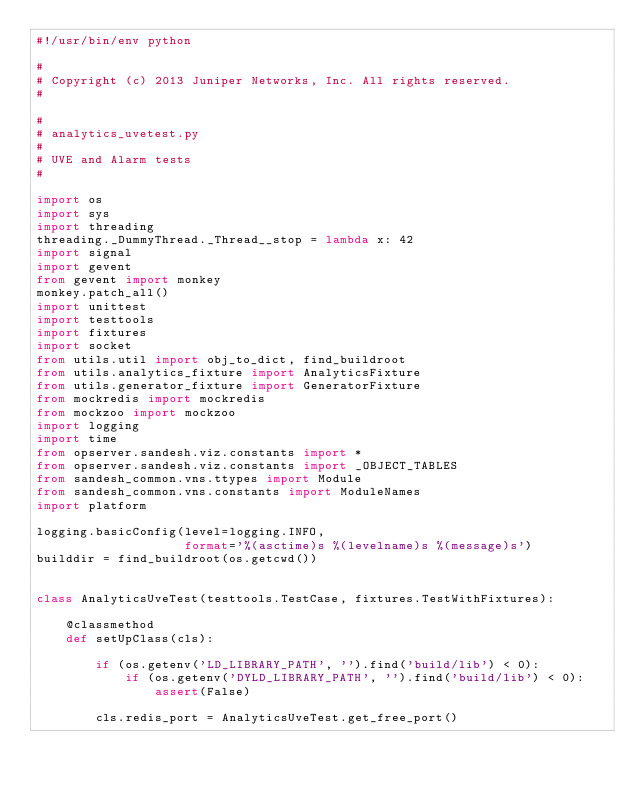Convert code to text. <code><loc_0><loc_0><loc_500><loc_500><_Python_>#!/usr/bin/env python

#
# Copyright (c) 2013 Juniper Networks, Inc. All rights reserved.
#

#
# analytics_uvetest.py
#
# UVE and Alarm tests
#

import os
import sys
import threading
threading._DummyThread._Thread__stop = lambda x: 42
import signal
import gevent
from gevent import monkey
monkey.patch_all()
import unittest
import testtools
import fixtures
import socket
from utils.util import obj_to_dict, find_buildroot
from utils.analytics_fixture import AnalyticsFixture
from utils.generator_fixture import GeneratorFixture
from mockredis import mockredis
from mockzoo import mockzoo
import logging
import time
from opserver.sandesh.viz.constants import *
from opserver.sandesh.viz.constants import _OBJECT_TABLES
from sandesh_common.vns.ttypes import Module
from sandesh_common.vns.constants import ModuleNames
import platform

logging.basicConfig(level=logging.INFO,
                    format='%(asctime)s %(levelname)s %(message)s')
builddir = find_buildroot(os.getcwd())


class AnalyticsUveTest(testtools.TestCase, fixtures.TestWithFixtures):

    @classmethod
    def setUpClass(cls):

        if (os.getenv('LD_LIBRARY_PATH', '').find('build/lib') < 0):
            if (os.getenv('DYLD_LIBRARY_PATH', '').find('build/lib') < 0):
                assert(False)

        cls.redis_port = AnalyticsUveTest.get_free_port()</code> 